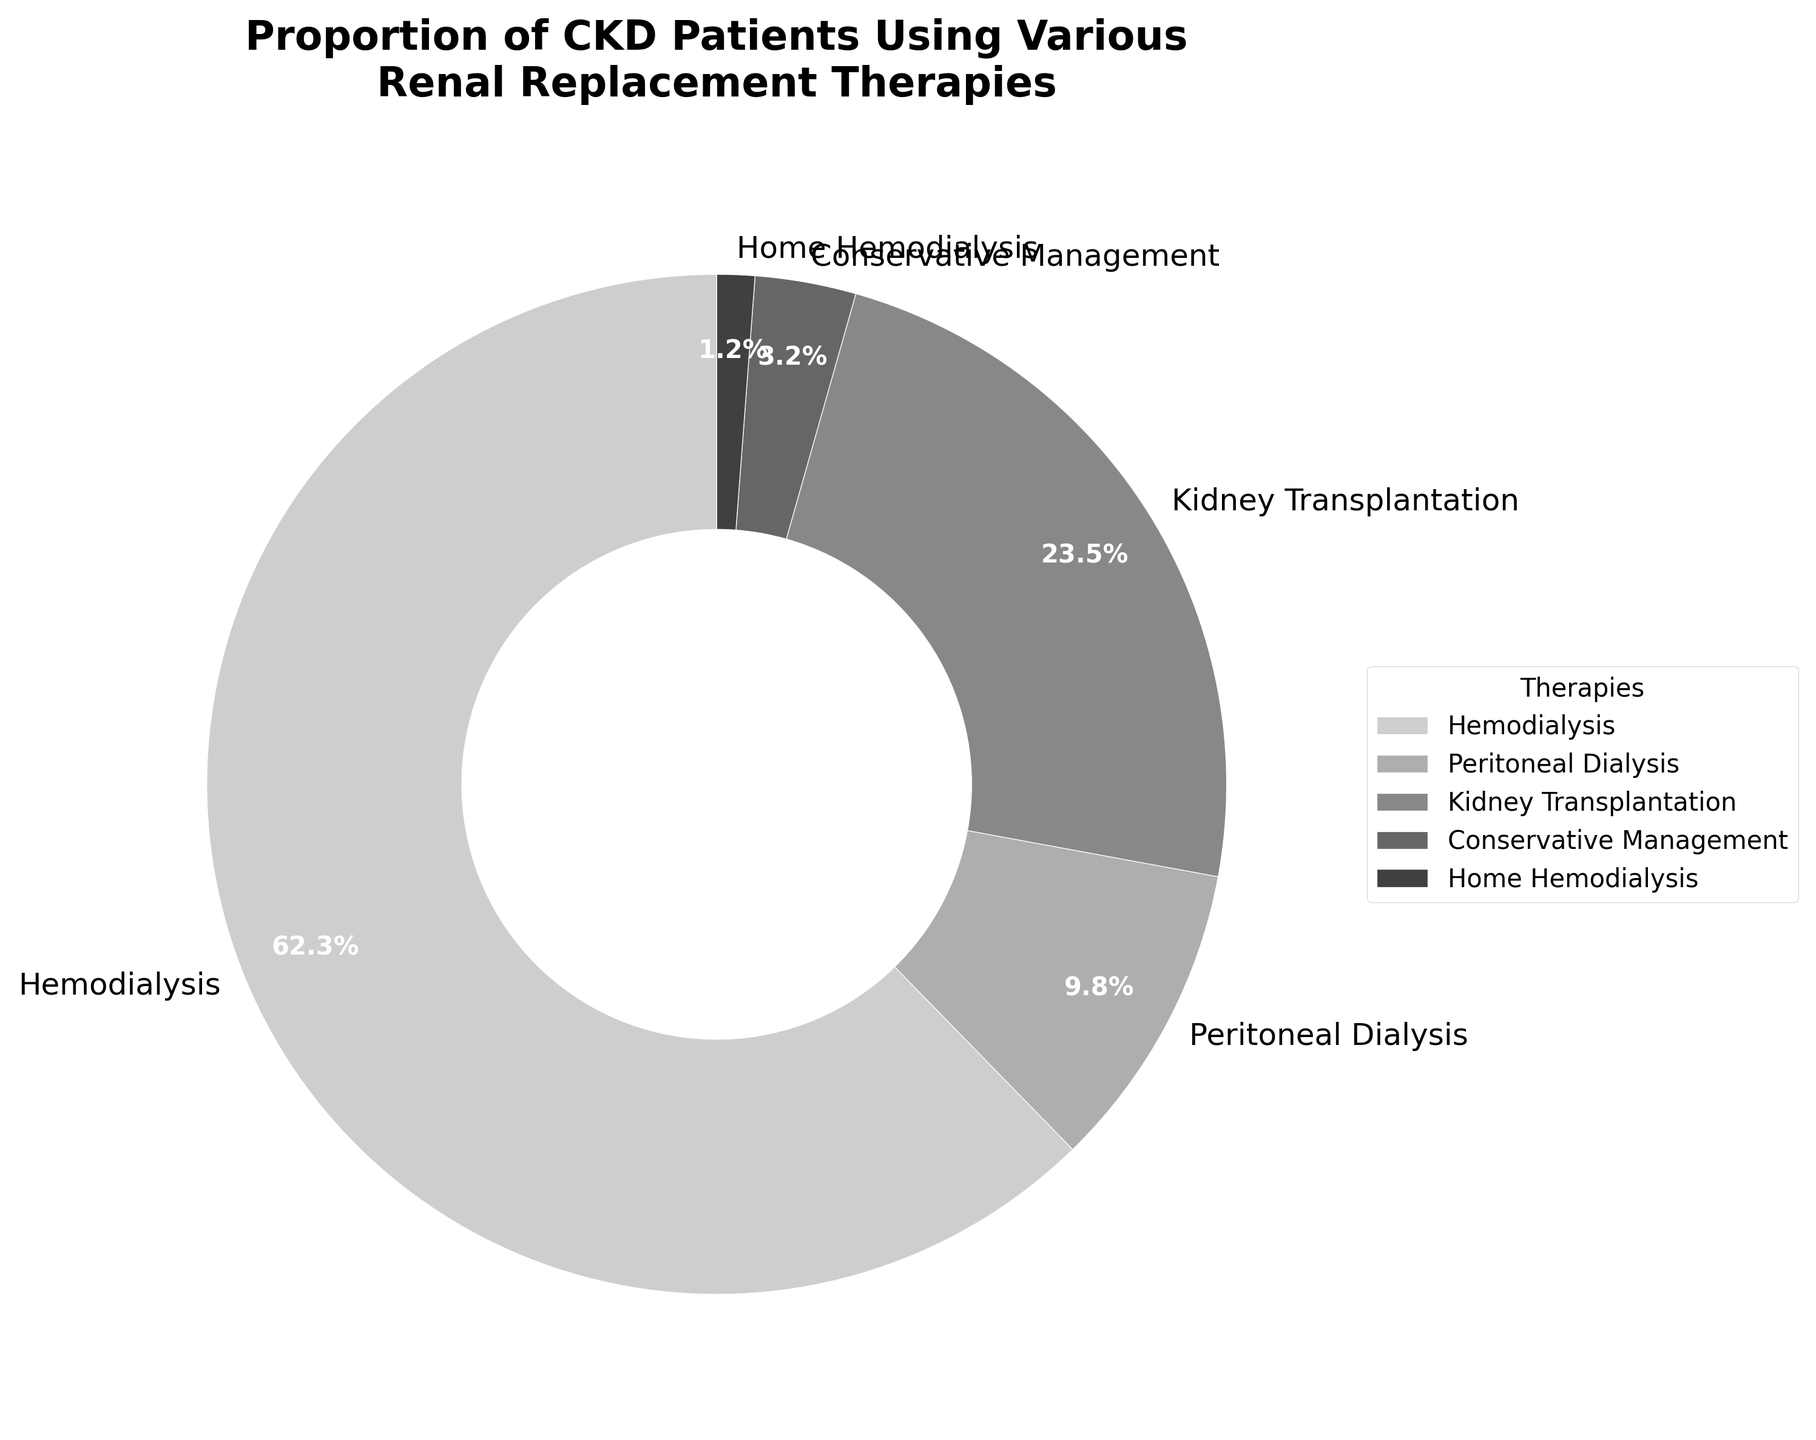What proportion of CKD patients use Hemodialysis compared to those using Peritoneal Dialysis? To determine the proportion, we compare the percentages directly from the chart: Hemodialysis (62.3%) and Peritoneal Dialysis (9.8%). Divide the percentage of Hemodialysis by the percentage of Peritoneal Dialysis: 62.3 / 9.8 ≈ 6.4. Hemodialysis is used by approximately 6.4 times more patients than Peritoneal Dialysis.
Answer: Hemodialysis is used by about 6.4 times more patients Which therapy has the smallest proportion of CKD patients, and what is its percentage? From the chart, identify the therapy with the smallest wedge. Home Hemodialysis appears to be the smallest segment. By checking the percentage associated with Home Hemodialysis, we see it is 1.2%.
Answer: Home Hemodialysis, 1.2% Which therapies combined account for more than half of the patient population? To find this, add the percentages of individual therapies: Hemodialysis (62.3%), Peritoneal Dialysis (9.8%), Kidney Transplantation (23.5%), Conservative Management (3.2%), Home Hemodialysis (1.2%). Hemodialysis alone is 62.3%, which is already greater than half (50%).
Answer: Hemodialysis What's the combined percentage of patients using Peritoneal Dialysis and Conservative Management? Add the percentages of Peritoneal Dialysis (9.8%) and Conservative Management (3.2%): 9.8 + 3.2 = 13.
Answer: 13% Is the proportion of patients using Kidney Transplantation greater than those using Hemodialysis and Home Hemodialysis combined? Sum the percentages for Hemodialysis (62.3%) and Home Hemodialysis (1.2%): 62.3 + 1.2 = 63.5%. Compare this with Kidney Transplantation (23.5%): 63.5% (Hemodialysis & Home Hemodialysis) vs. 23.5% (Kidney Transplantation). Kidney Transplantation is less than the combined Hemodialysis and Home Hemodialysis percentage.
Answer: No Among the therapies, which two have the closest percentages, and what are their values? By observing the percentages, identify the two closest values. Peritoneal Dialysis (9.8%) and Conservative Management (3.2%) are closest. Their absolute difference is 9.8 - 3.2 = 6.6.
Answer: Peritoneal Dialysis (9.8%) and Conservative Management (3.2%) What's the difference in percentage between Kidney Transplantation and Home Hemodialysis? Identify the percentages for Kidney Transplantation (23.5%) and Home Hemodialysis (1.2%). Subtract the smaller percentage from the larger: 23.5 - 1.2 = 22.3.
Answer: 22.3% How many times larger is the percentage of patients using Hemodialysis compared to those using Conservative Management? Divide the percentage of Hemodialysis (62.3%) by the percentage of Conservative Management (3.2%): 62.3 / 3.2 ≈ 19.5. Thus, Hemodialysis is approximately 19.5 times larger.
Answer: About 19.5 times What is the average percentage of patients using any of the therapies? Add the percentages of all therapies: 62.3+9.8+23.5+3.2+1.2 = 100%. The total number of therapies is 5. Compute the average: 100 / 5 = 20.
Answer: 20% What would be the combined percentage if Home Hemodialysis and Conservative Management were merged into a single category? Combine the percentages: Home Hemodialysis (1.2%) + Conservative Management (3.2%) = 4.4%.
Answer: 4.4% 